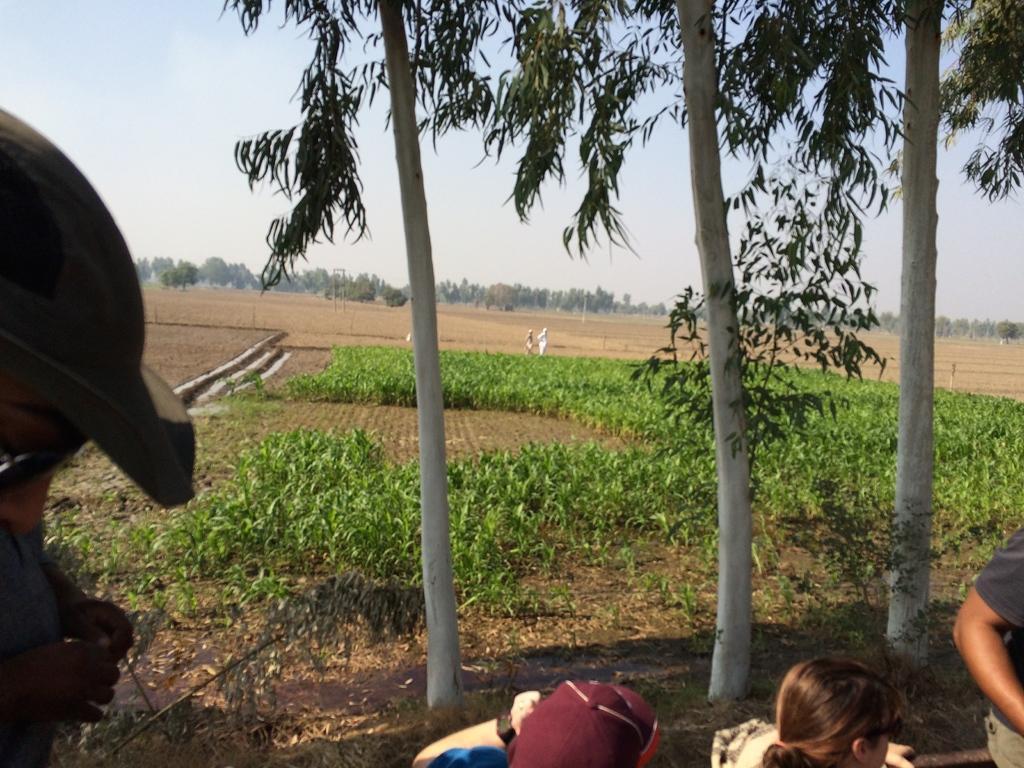Can you describe this image briefly? In this picture we can see a land with mud, plants and trees. The sky is blue. 